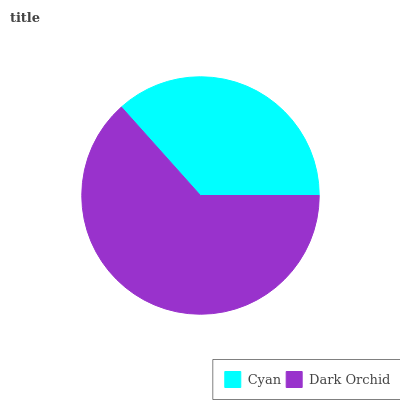Is Cyan the minimum?
Answer yes or no. Yes. Is Dark Orchid the maximum?
Answer yes or no. Yes. Is Dark Orchid the minimum?
Answer yes or no. No. Is Dark Orchid greater than Cyan?
Answer yes or no. Yes. Is Cyan less than Dark Orchid?
Answer yes or no. Yes. Is Cyan greater than Dark Orchid?
Answer yes or no. No. Is Dark Orchid less than Cyan?
Answer yes or no. No. Is Dark Orchid the high median?
Answer yes or no. Yes. Is Cyan the low median?
Answer yes or no. Yes. Is Cyan the high median?
Answer yes or no. No. Is Dark Orchid the low median?
Answer yes or no. No. 